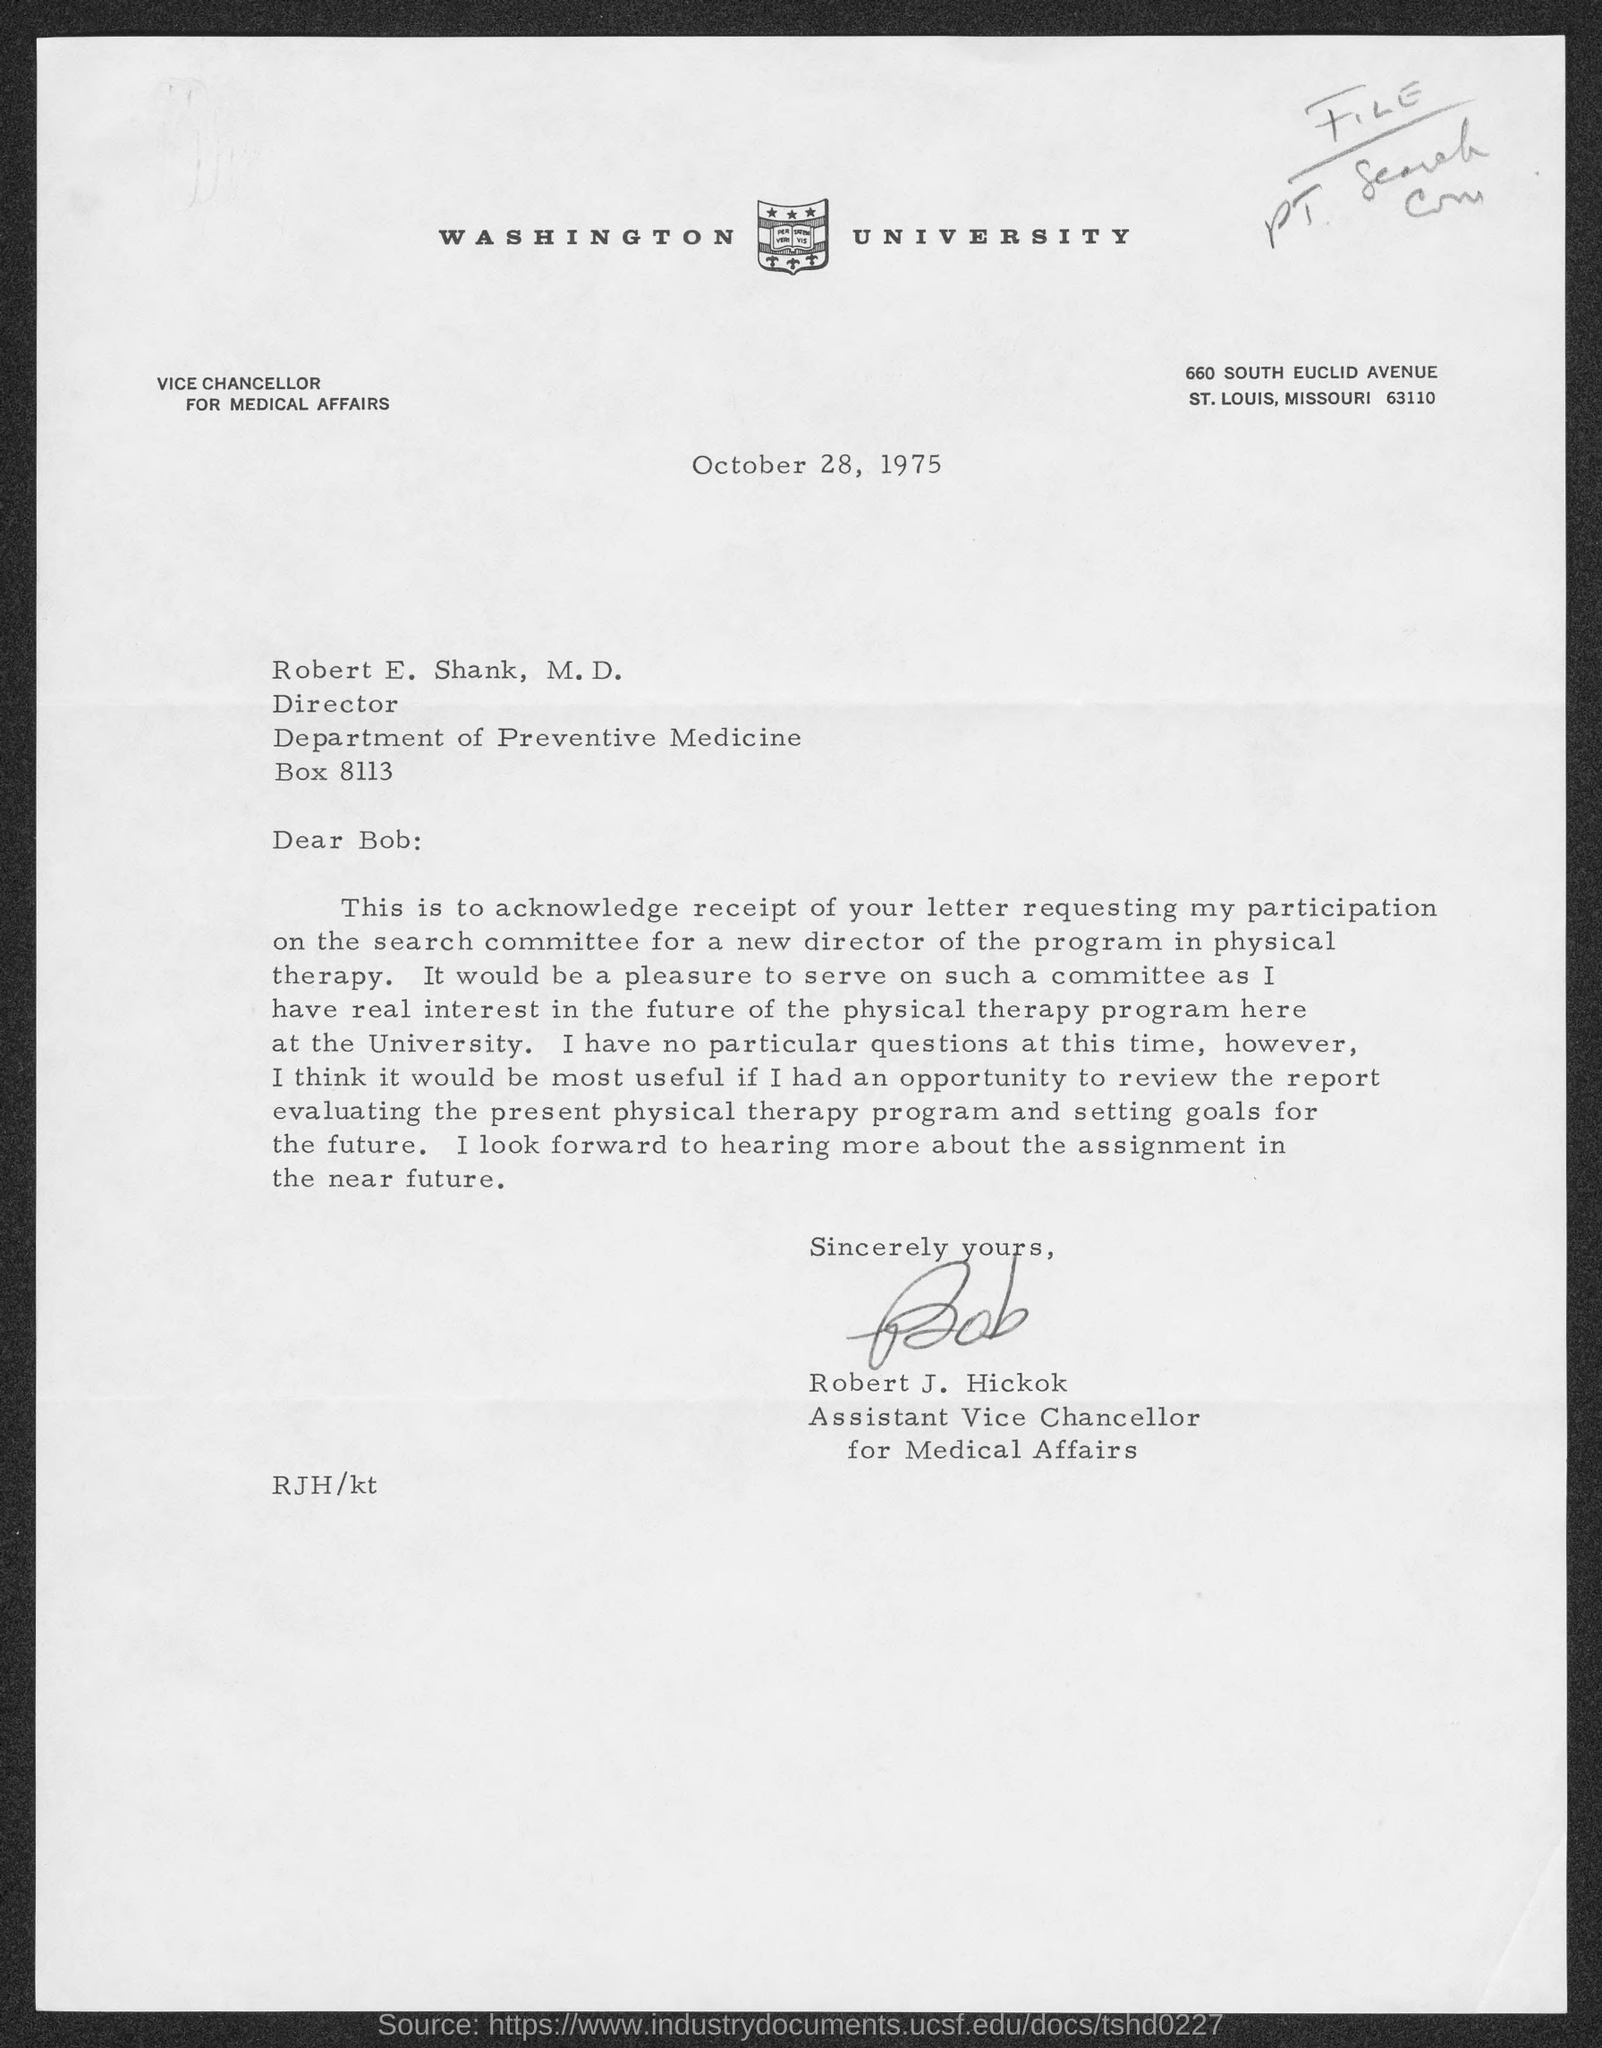What is the date?
Make the answer very short. October 28, 1975. What is the salutation of this letter?
Your response must be concise. Dear Bob:. 